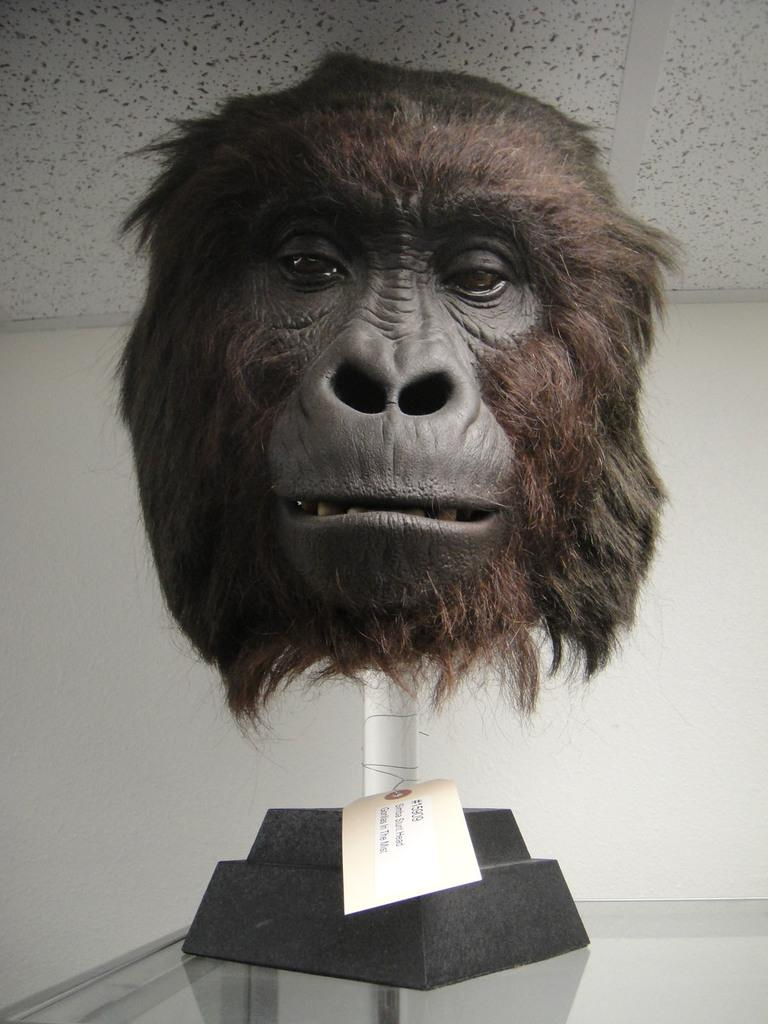What is the main subject in the center of the image? There is a head of a chimpanzee in the center of the image. What can be seen in the background of the image? There is a wall in the background of the image. What object is located at the bottom of the image? There is a glass at the bottom of the image. How does the chimpanzee sort the objects in the image? The image does not show the chimpanzee sorting any objects, as it only depicts the head of a chimpanzee. 